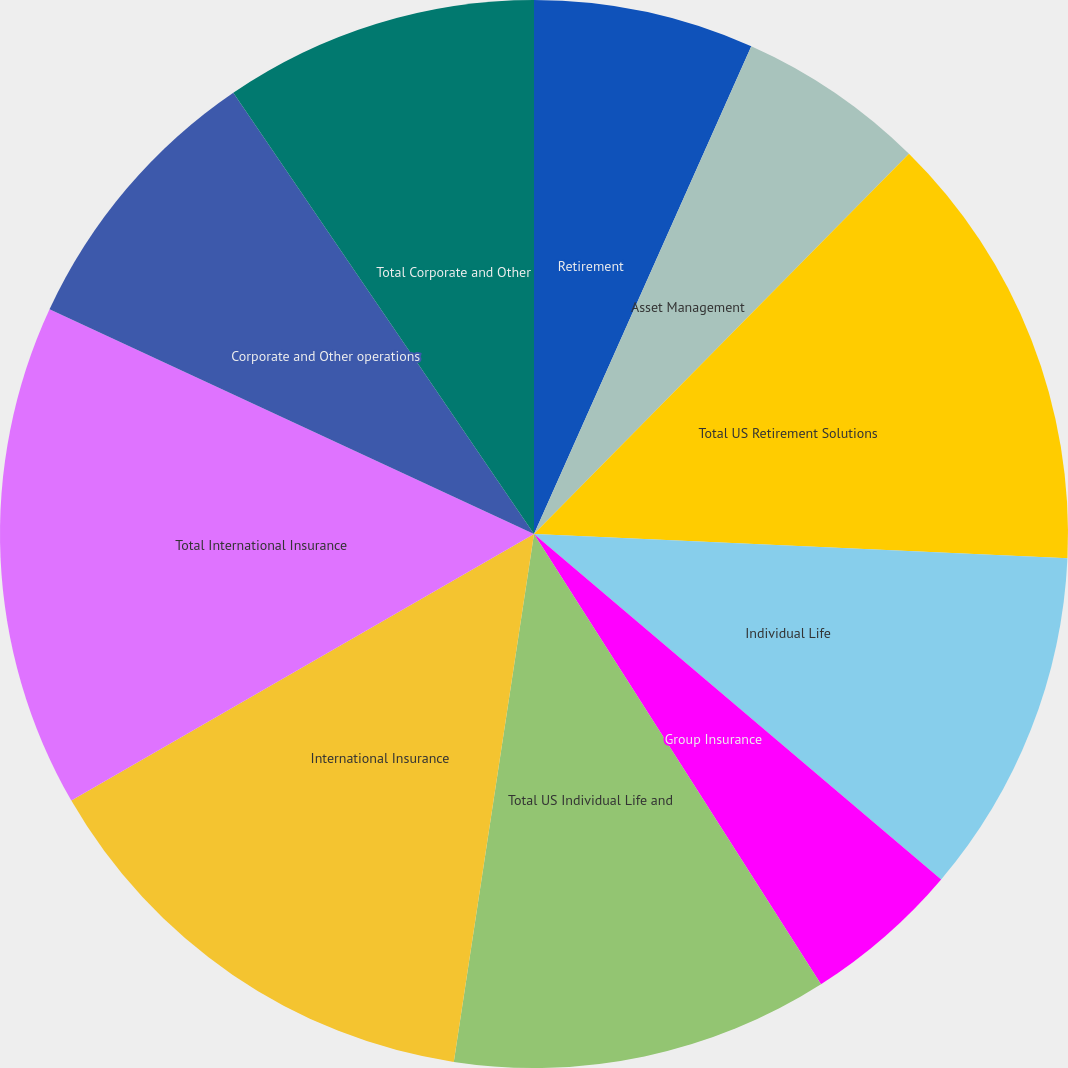Convert chart. <chart><loc_0><loc_0><loc_500><loc_500><pie_chart><fcel>Retirement<fcel>Asset Management<fcel>Total US Retirement Solutions<fcel>Individual Life<fcel>Group Insurance<fcel>Total US Individual Life and<fcel>International Insurance<fcel>Total International Insurance<fcel>Corporate and Other operations<fcel>Total Corporate and Other<nl><fcel>6.67%<fcel>5.72%<fcel>13.33%<fcel>10.48%<fcel>4.77%<fcel>11.43%<fcel>14.28%<fcel>15.23%<fcel>8.57%<fcel>9.52%<nl></chart> 